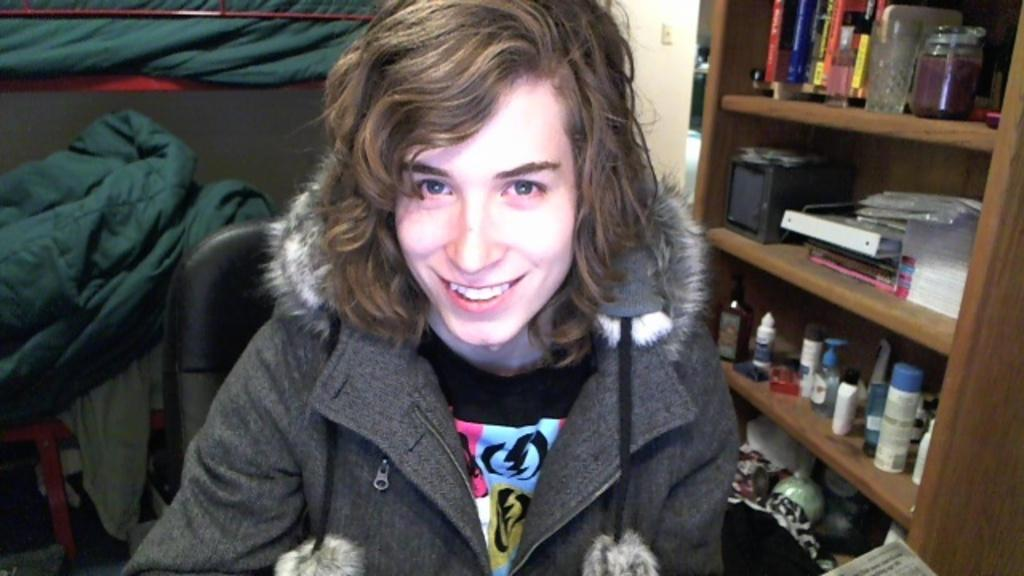What is the person in the image doing? There is a person sitting on a chair in the image. What can be seen on the left side of the image? There are objects on the left side of the image. Where are many objects placed in the image? There are many objects placed on shelves in the image. What type of potato is being used for the person's hobbies in the image? There is no potato present in the image, nor is there any indication of the person's hobbies. What journey is the person taking in the image? There is no journey depicted in the image; the person is simply sitting on a chair. 